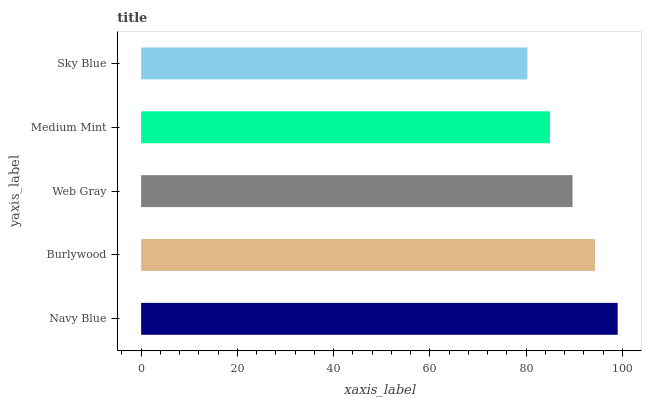Is Sky Blue the minimum?
Answer yes or no. Yes. Is Navy Blue the maximum?
Answer yes or no. Yes. Is Burlywood the minimum?
Answer yes or no. No. Is Burlywood the maximum?
Answer yes or no. No. Is Navy Blue greater than Burlywood?
Answer yes or no. Yes. Is Burlywood less than Navy Blue?
Answer yes or no. Yes. Is Burlywood greater than Navy Blue?
Answer yes or no. No. Is Navy Blue less than Burlywood?
Answer yes or no. No. Is Web Gray the high median?
Answer yes or no. Yes. Is Web Gray the low median?
Answer yes or no. Yes. Is Navy Blue the high median?
Answer yes or no. No. Is Sky Blue the low median?
Answer yes or no. No. 